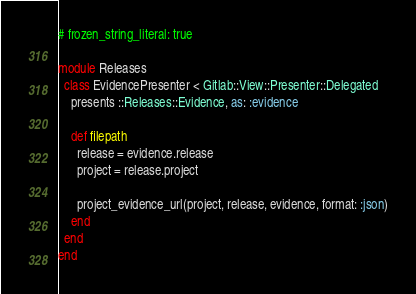<code> <loc_0><loc_0><loc_500><loc_500><_Ruby_># frozen_string_literal: true

module Releases
  class EvidencePresenter < Gitlab::View::Presenter::Delegated
    presents ::Releases::Evidence, as: :evidence

    def filepath
      release = evidence.release
      project = release.project

      project_evidence_url(project, release, evidence, format: :json)
    end
  end
end
</code> 